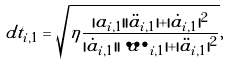<formula> <loc_0><loc_0><loc_500><loc_500>d t _ { i , 1 } = \sqrt { \eta \frac { | a _ { i , 1 } | | \ddot { a } _ { i , 1 } | + | \dot { a } _ { i , 1 } | ^ { 2 } } { | \dot { a } _ { i , 1 } | | \dddot { a } _ { i , 1 } | + | \ddot { a } _ { i , 1 } | ^ { 2 } } } ,</formula> 